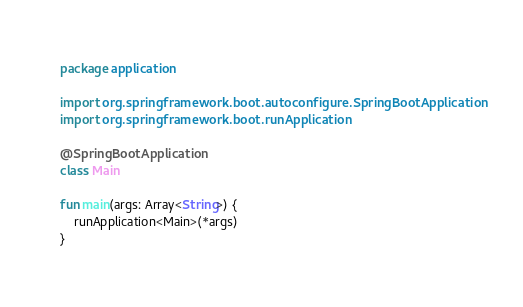<code> <loc_0><loc_0><loc_500><loc_500><_Kotlin_>package application

import org.springframework.boot.autoconfigure.SpringBootApplication
import org.springframework.boot.runApplication

@SpringBootApplication
class Main

fun main(args: Array<String>) {
    runApplication<Main>(*args)
}

</code> 